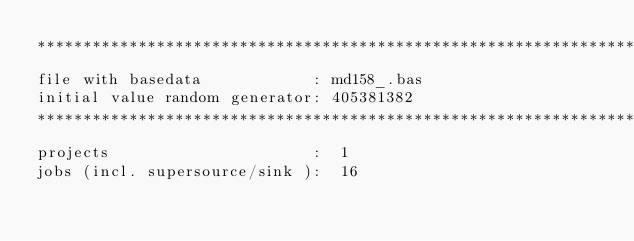Convert code to text. <code><loc_0><loc_0><loc_500><loc_500><_ObjectiveC_>************************************************************************
file with basedata            : md158_.bas
initial value random generator: 405381382
************************************************************************
projects                      :  1
jobs (incl. supersource/sink ):  16</code> 